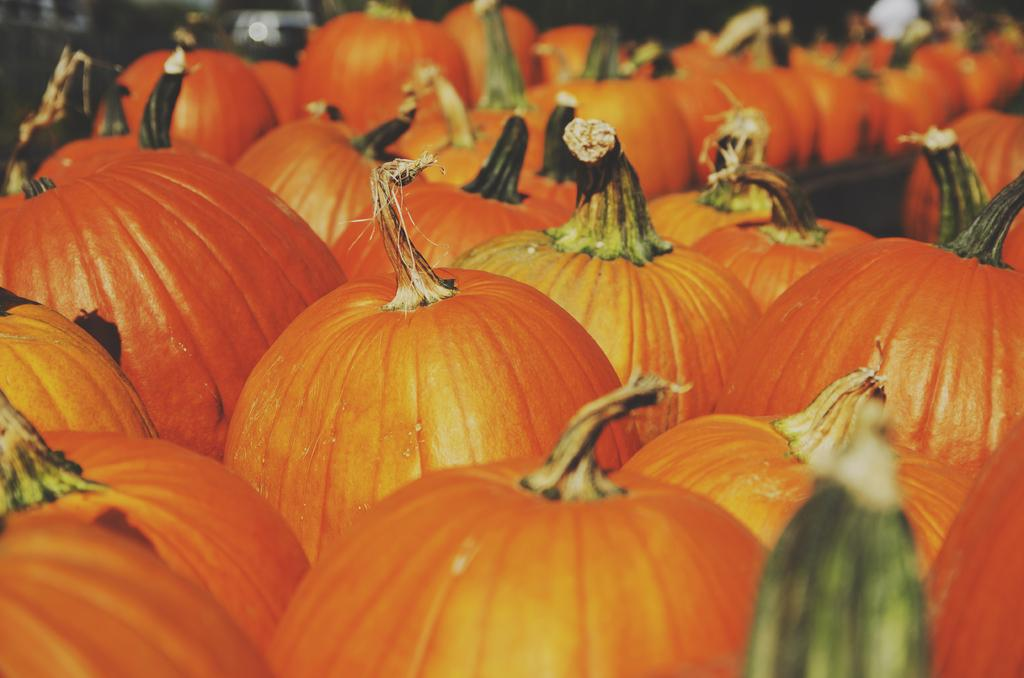What type of vegetable is present in the image? There are pumpkins in the image. What color are the pumpkins? The pumpkins are orange in color. Can you describe the butter on the pumpkins in the image? There is no butter present on the pumpkins in the image. 